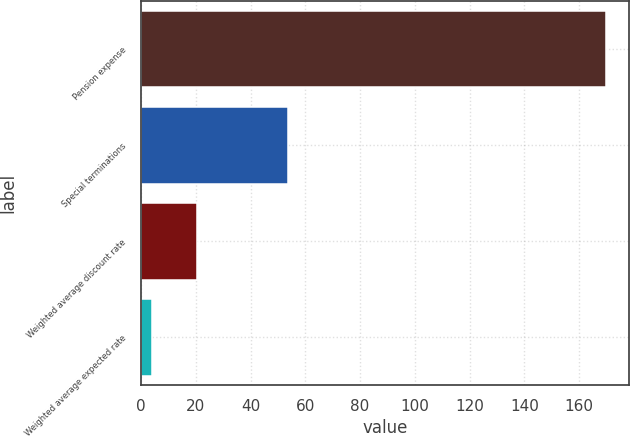Convert chart to OTSL. <chart><loc_0><loc_0><loc_500><loc_500><bar_chart><fcel>Pension expense<fcel>Special terminations<fcel>Weighted average discount rate<fcel>Weighted average expected rate<nl><fcel>169.7<fcel>53.57<fcel>20.39<fcel>3.8<nl></chart> 